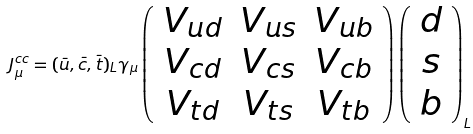Convert formula to latex. <formula><loc_0><loc_0><loc_500><loc_500>J ^ { c c } _ { \mu } = ( \bar { u } , \bar { c } , \bar { t } ) _ { L } \gamma _ { \mu } \left ( \begin{array} { c c c } V _ { u d } & V _ { u s } & V _ { u b } \\ V _ { c d } & V _ { c s } & V _ { c b } \\ V _ { t d } & V _ { t s } & V _ { t b } \end{array} \right ) \left ( \begin{array} { c } d \\ s \\ b \end{array} \right ) _ { L }</formula> 